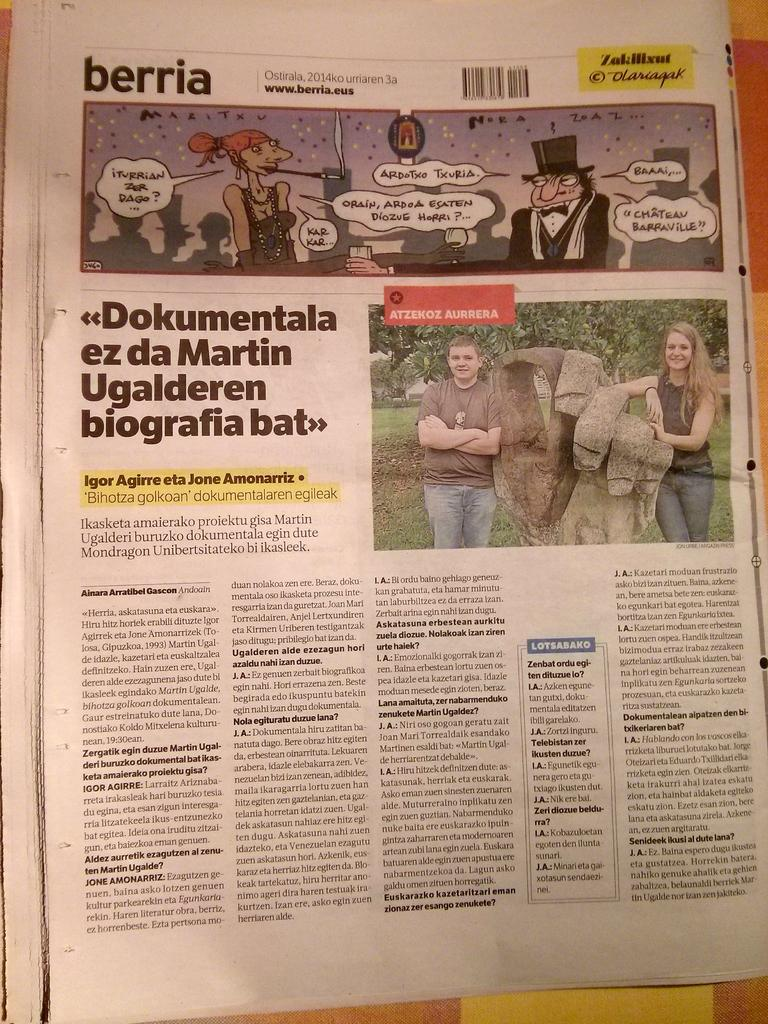What is depicted on the paper in the image? There are pictures and articles on the paper in the image. What type of content can be found on the paper? The paper contains both pictures and articles. What type of arch can be seen in the image? There is no arch present in the image; it features pictures and articles on a paper. How does the knee relate to the content of the image? The knee does not relate to the content of the image, as it features pictures and articles on a paper. 